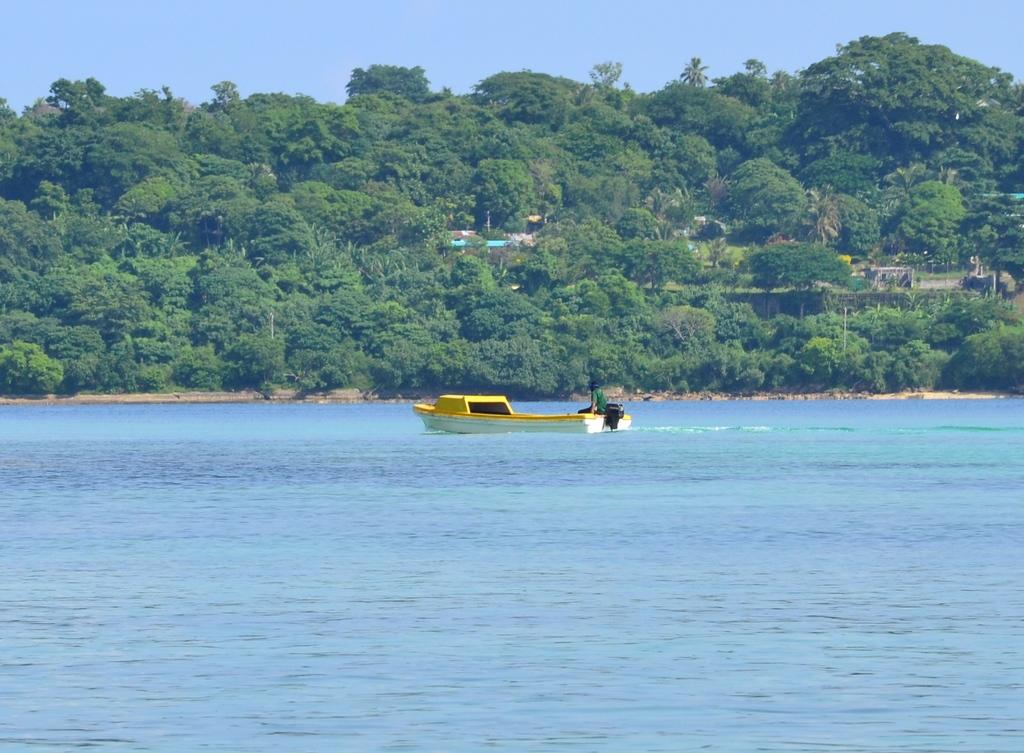What is the person in the image doing? The person is sitting on a motor boat in the image. Where is the motor boat located? The motor boat is in the water. What can be seen in the background of the image? There are trees in the background of the image. What type of lunch is being served on the stage in the image? There is no stage or lunch present in the image; it features a person sitting on a motor boat in the water with trees in the background. 